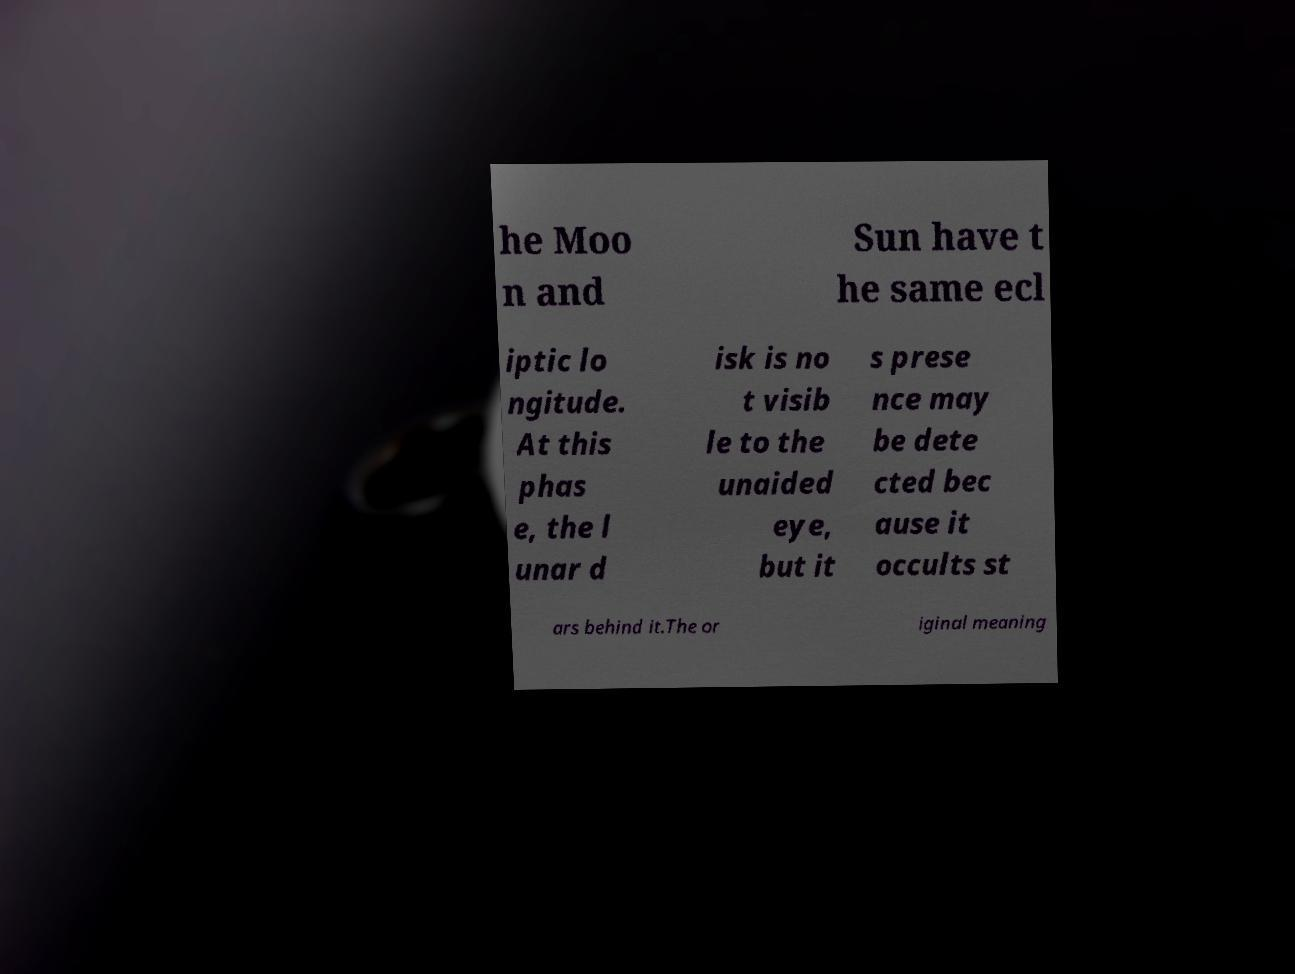For documentation purposes, I need the text within this image transcribed. Could you provide that? he Moo n and Sun have t he same ecl iptic lo ngitude. At this phas e, the l unar d isk is no t visib le to the unaided eye, but it s prese nce may be dete cted bec ause it occults st ars behind it.The or iginal meaning 